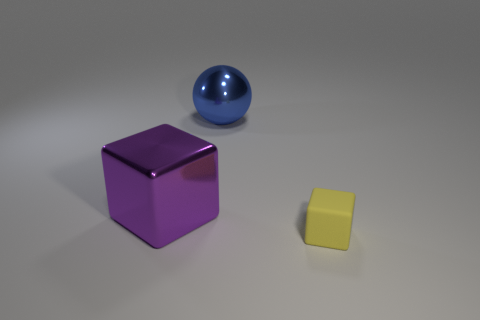Add 3 large metallic spheres. How many objects exist? 6 Subtract all large brown rubber things. Subtract all purple objects. How many objects are left? 2 Add 2 blue things. How many blue things are left? 3 Add 2 purple balls. How many purple balls exist? 2 Subtract 0 yellow spheres. How many objects are left? 3 Subtract all cubes. How many objects are left? 1 